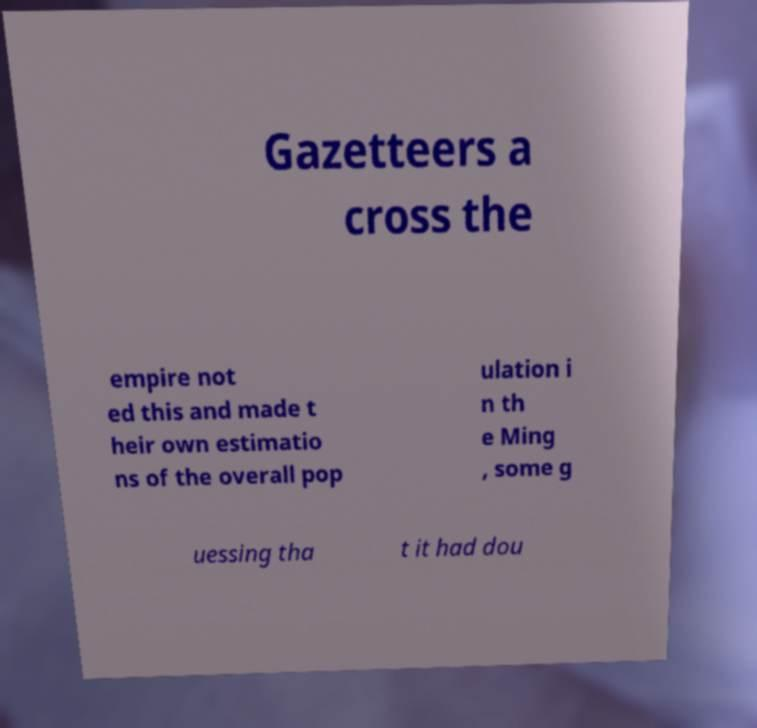I need the written content from this picture converted into text. Can you do that? Gazetteers a cross the empire not ed this and made t heir own estimatio ns of the overall pop ulation i n th e Ming , some g uessing tha t it had dou 